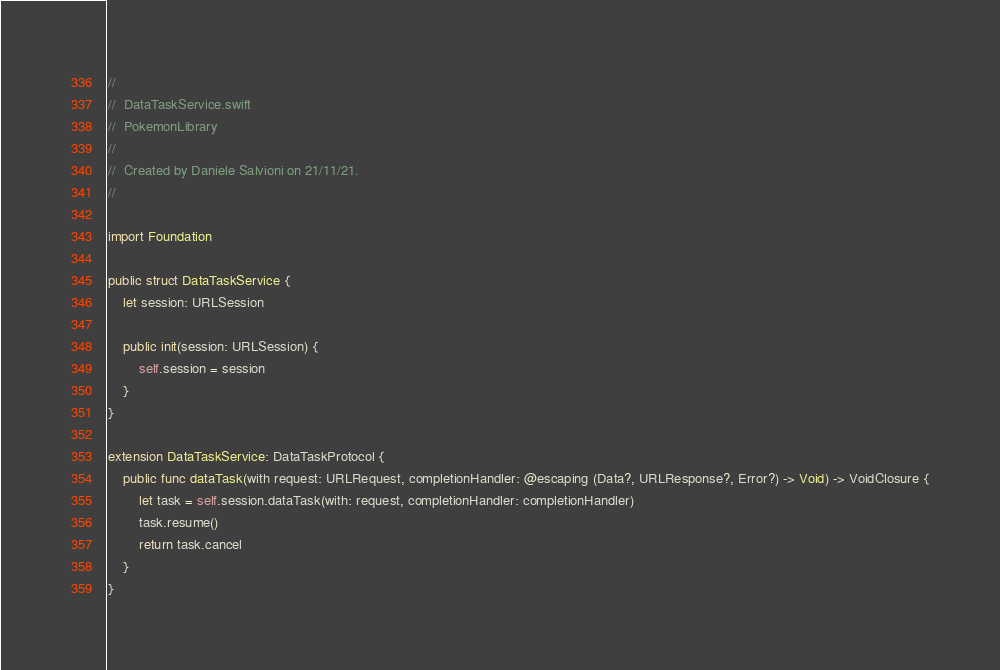<code> <loc_0><loc_0><loc_500><loc_500><_Swift_>//
//  DataTaskService.swift
//  PokemonLibrary
//
//  Created by Daniele Salvioni on 21/11/21.
//

import Foundation

public struct DataTaskService {
    let session: URLSession
    
    public init(session: URLSession) {
        self.session = session
    }
}

extension DataTaskService: DataTaskProtocol {
    public func dataTask(with request: URLRequest, completionHandler: @escaping (Data?, URLResponse?, Error?) -> Void) -> VoidClosure {
        let task = self.session.dataTask(with: request, completionHandler: completionHandler)
        task.resume()
        return task.cancel
    }
}
</code> 